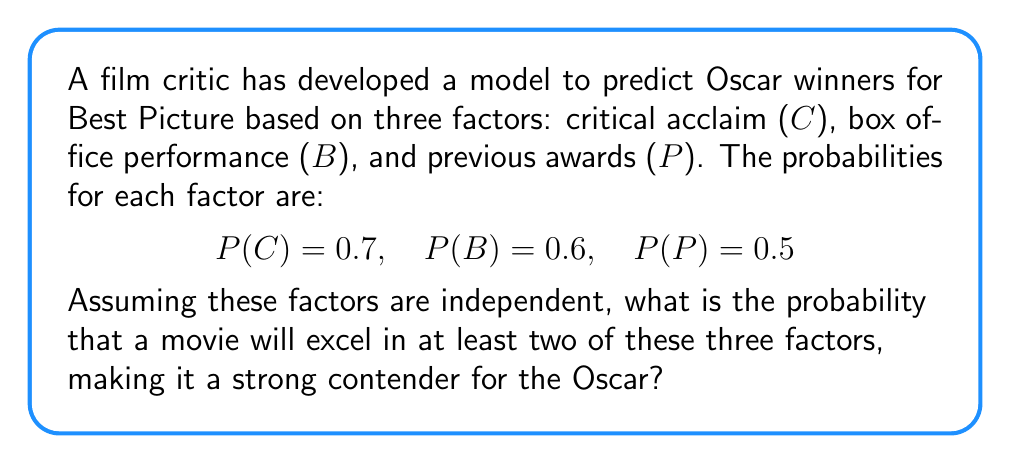Show me your answer to this math problem. Let's approach this step-by-step:

1) First, we need to calculate the probability of a movie excelling in each factor:
   P(C) = 0.7
   P(B) = 0.6
   P(P) = 0.5

2) The probability of not excelling in each factor is:
   P(not C) = 1 - 0.7 = 0.3
   P(not B) = 1 - 0.6 = 0.4
   P(not P) = 1 - 0.5 = 0.5

3) We want the probability of excelling in at least two factors. It's easier to calculate the complement of this: the probability of excelling in one or zero factors.

4) Probability of excelling in zero factors:
   $$P(\text{zero}) = 0.3 \times 0.4 \times 0.5 = 0.06$$

5) Probability of excelling in exactly one factor:
   $$P(\text{C only}) = 0.7 \times 0.4 \times 0.5 = 0.14$$
   $$P(\text{B only}) = 0.3 \times 0.6 \times 0.5 = 0.09$$
   $$P(\text{P only}) = 0.3 \times 0.4 \times 0.5 = 0.06$$

   $$P(\text{one}) = 0.14 + 0.09 + 0.06 = 0.29$$

6) Probability of excelling in zero or one factor:
   $$P(\text{zero or one}) = 0.06 + 0.29 = 0.35$$

7) Therefore, the probability of excelling in at least two factors is:
   $$P(\text{at least two}) = 1 - P(\text{zero or one}) = 1 - 0.35 = 0.65$$
Answer: 0.65 